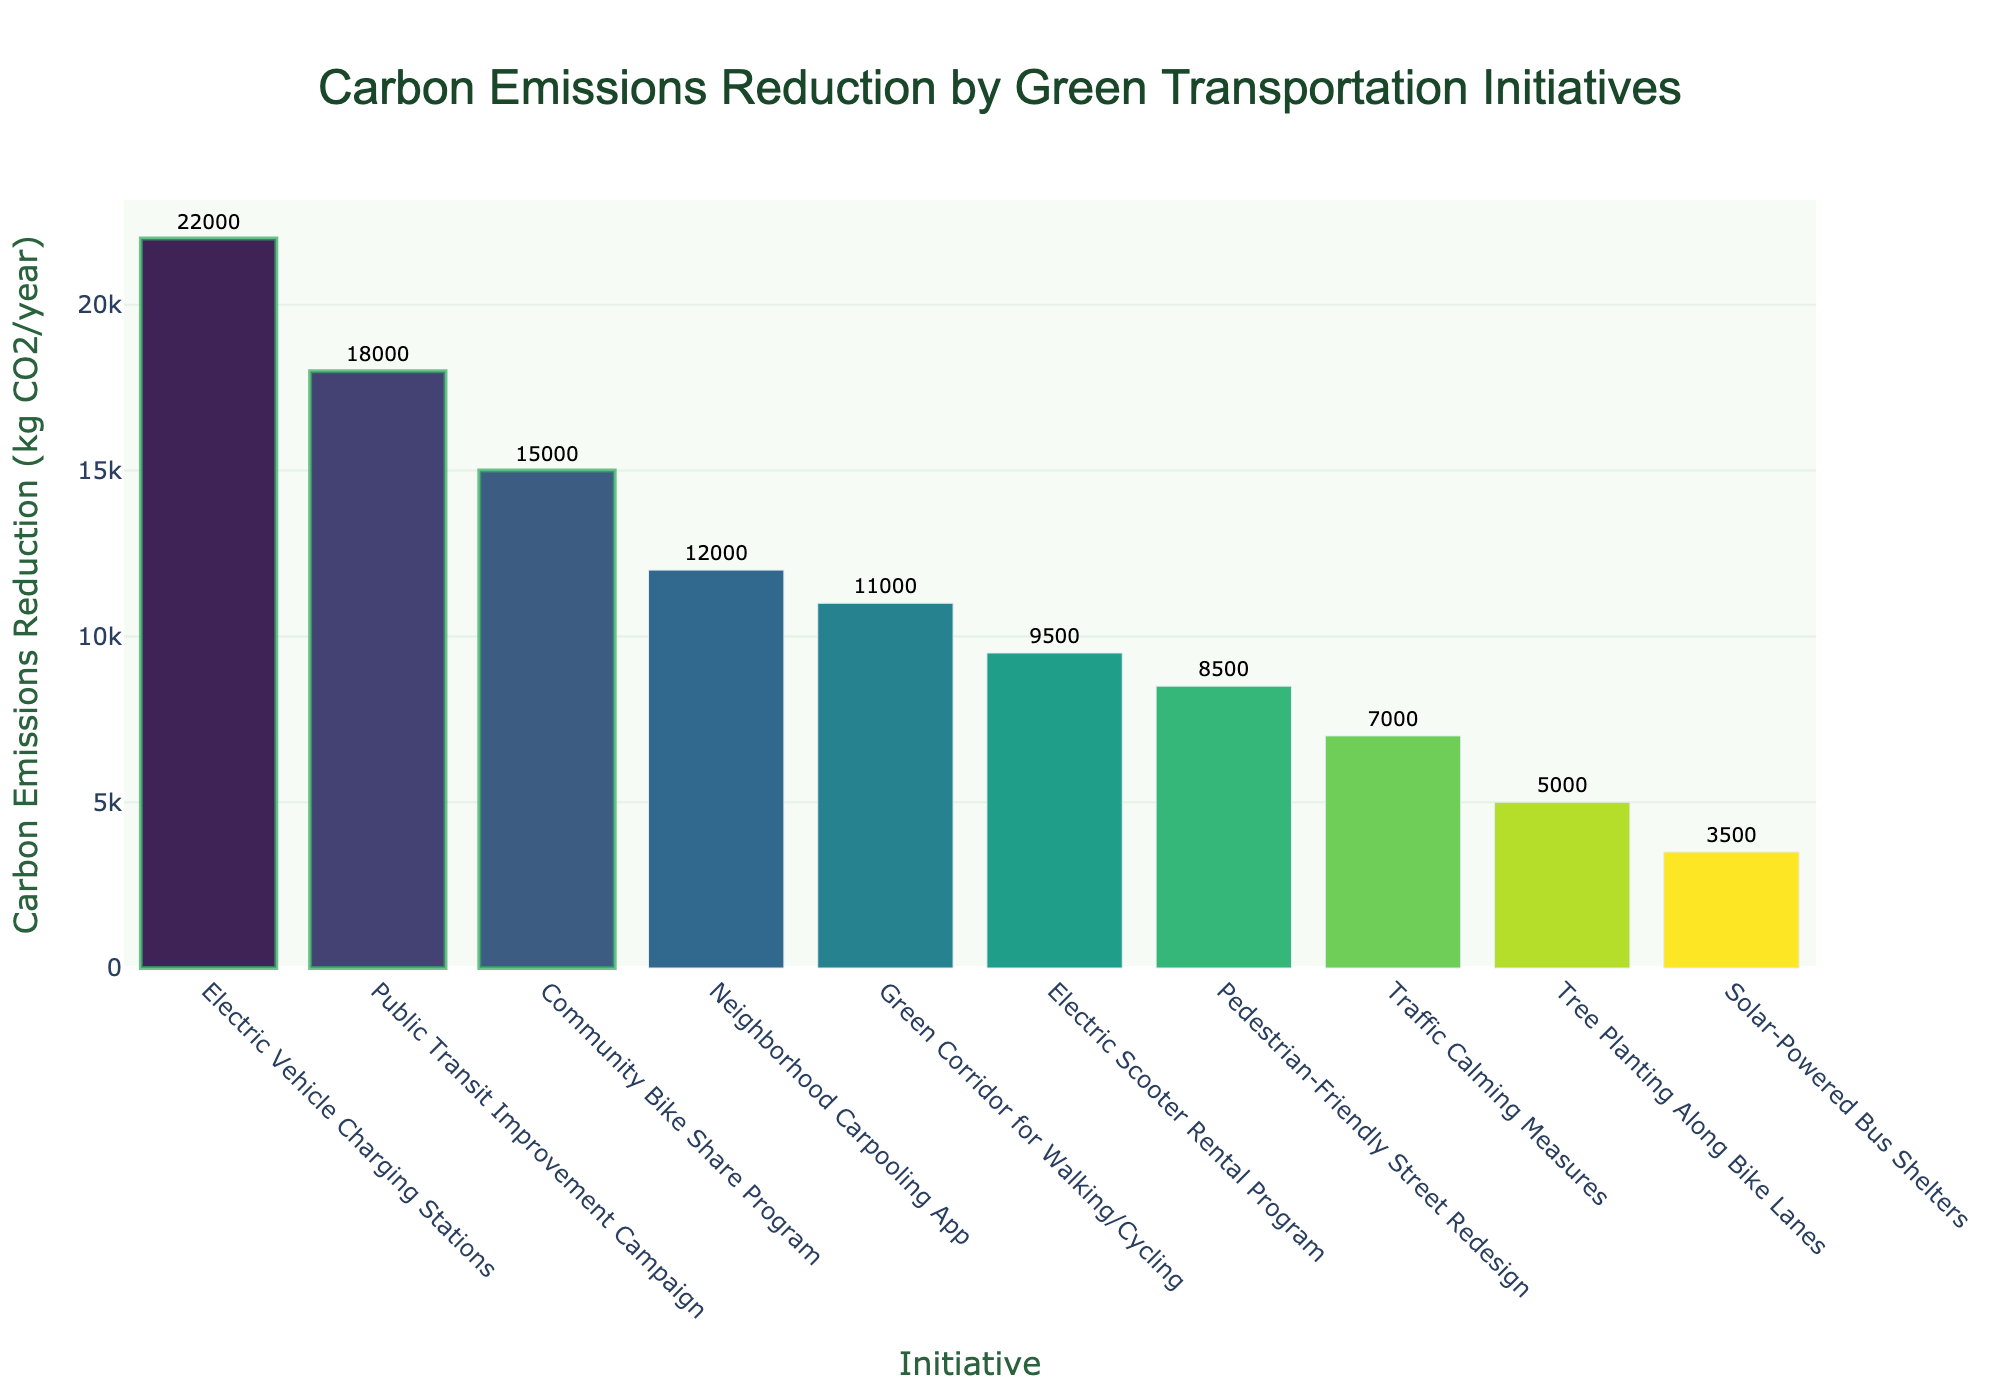What's the initiative with the highest carbon emissions reduction? The figure shows the tallest bar for the "Electric Vehicle Charging Stations" initiative.
Answer: Electric Vehicle Charging Stations Which two initiatives combined have the smallest carbon emissions reduction? Looking at the shortest bars, "Solar-Powered Bus Shelters" and "Tree Planting Along Bike Lanes" have the smallest values: 3500 and 5000 kg CO2/year respectively.
Answer: Solar-Powered Bus Shelters and Tree Planting Along Bike Lanes How much more carbon emissions reduction does the "Public Transit Improvement Campaign" achieve compared to "Electric Scooter Rental Program"? "Public Transit Improvement Campaign" has 18000 kg CO2/year and "Electric Scooter Rental Program" has 9500 kg CO2/year, so the difference is 18000 - 9500.
Answer: 8500 kg CO2/year What’s the total carbon emissions reduction contributed by the top three initiatives? The top three initiatives are "Electric Vehicle Charging Stations" (22000 kg), "Public Transit Improvement Campaign" (18000 kg), and "Community Bike Share Program" (15000 kg). Summing these gives 22000 + 18000 + 15000.
Answer: 55000 kg CO2/year Of the highlighted initiatives, which has the least carbon emissions reduction? Among the highlighted (top 3) initiatives, "Community Bike Share Program" has the least reduction at 15000 kg CO2/year.
Answer: Community Bike Share Program What is the difference in carbon emissions reduction achieved by "Community Bike Share Program" and "Neighborhood Carpooling App"? "Community Bike Share Program" achieves 15000 kg CO2/year, while "Neighborhood Carpooling App" achieves 12000 kg CO2/year. The difference is 15000 - 12000.
Answer: 3000 kg CO2/year Which initiative ranks the fifth in terms of carbon emissions reduction? The fifth highest bar corresponds to the "Neighborhood Carpooling App" with 12000 kg CO2/year.
Answer: Neighborhood Carpooling App What’s the average carbon emissions reduction of the bottom three initiatives? The bottom three initiatives are "Solar-Powered Bus Shelters" (3500 kg), "Tree Planting Along Bike Lanes" (5000 kg), and "Traffic Calming Measures" (7000 kg). Their average is (3500 + 5000 + 7000) / 3.
Answer: 5167 kg CO2/year Which two initiatives are closest in terms of carbon emissions reduction? The "Electric Scooter Rental Program" (9500 kg) and "Green Corridor for Walking/Cycling" (11000 kg) are close with a difference of 1500 kg CO2/year.
Answer: Electric Scooter Rental Program and Green Corridor for Walking/Cycling What is the total carbon emissions reduction achieved by all initiatives combined? Adding up all the values: 3500 + 5000 + 7000 + 8500 + 9500 + 11000 + 12000 + 15000 + 18000 + 22000.
Answer: 111000 kg CO2/year 